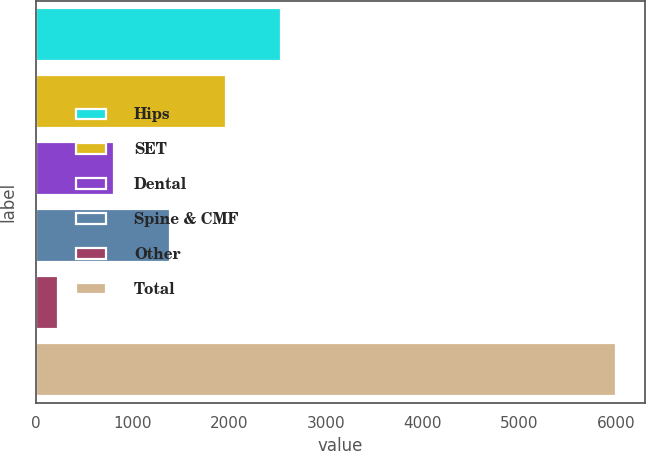<chart> <loc_0><loc_0><loc_500><loc_500><bar_chart><fcel>Hips<fcel>SET<fcel>Dental<fcel>Spine & CMF<fcel>Other<fcel>Total<nl><fcel>2536.4<fcel>1959.5<fcel>805.7<fcel>1382.6<fcel>228.8<fcel>5997.8<nl></chart> 